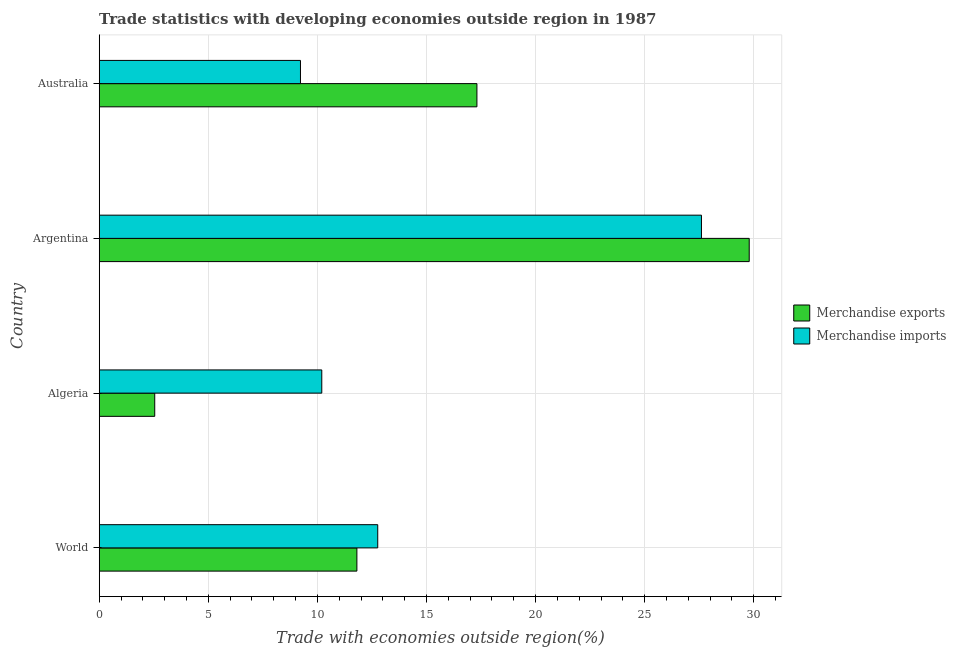Are the number of bars per tick equal to the number of legend labels?
Provide a succinct answer. Yes. How many bars are there on the 1st tick from the bottom?
Keep it short and to the point. 2. What is the label of the 2nd group of bars from the top?
Keep it short and to the point. Argentina. What is the merchandise exports in World?
Offer a very short reply. 11.81. Across all countries, what is the maximum merchandise imports?
Make the answer very short. 27.6. Across all countries, what is the minimum merchandise exports?
Offer a very short reply. 2.54. In which country was the merchandise imports minimum?
Keep it short and to the point. Australia. What is the total merchandise imports in the graph?
Offer a terse response. 59.79. What is the difference between the merchandise imports in World and the merchandise exports in Australia?
Your answer should be compact. -4.55. What is the average merchandise imports per country?
Your answer should be very brief. 14.95. What is the difference between the merchandise exports and merchandise imports in World?
Ensure brevity in your answer.  -0.95. What is the ratio of the merchandise exports in Argentina to that in World?
Provide a succinct answer. 2.52. Is the merchandise exports in Australia less than that in World?
Give a very brief answer. No. Is the difference between the merchandise imports in Algeria and Australia greater than the difference between the merchandise exports in Algeria and Australia?
Your answer should be very brief. Yes. What is the difference between the highest and the second highest merchandise exports?
Give a very brief answer. 12.48. What is the difference between the highest and the lowest merchandise imports?
Your response must be concise. 18.38. What does the 2nd bar from the top in World represents?
Your answer should be compact. Merchandise exports. What does the 1st bar from the bottom in World represents?
Offer a terse response. Merchandise exports. How many bars are there?
Offer a very short reply. 8. Are all the bars in the graph horizontal?
Give a very brief answer. Yes. How many countries are there in the graph?
Keep it short and to the point. 4. Are the values on the major ticks of X-axis written in scientific E-notation?
Offer a very short reply. No. Does the graph contain any zero values?
Keep it short and to the point. No. Does the graph contain grids?
Provide a succinct answer. Yes. Where does the legend appear in the graph?
Ensure brevity in your answer.  Center right. How are the legend labels stacked?
Your response must be concise. Vertical. What is the title of the graph?
Offer a terse response. Trade statistics with developing economies outside region in 1987. What is the label or title of the X-axis?
Your answer should be compact. Trade with economies outside region(%). What is the label or title of the Y-axis?
Provide a succinct answer. Country. What is the Trade with economies outside region(%) in Merchandise exports in World?
Ensure brevity in your answer.  11.81. What is the Trade with economies outside region(%) of Merchandise imports in World?
Ensure brevity in your answer.  12.76. What is the Trade with economies outside region(%) in Merchandise exports in Algeria?
Give a very brief answer. 2.54. What is the Trade with economies outside region(%) of Merchandise imports in Algeria?
Your answer should be very brief. 10.2. What is the Trade with economies outside region(%) in Merchandise exports in Argentina?
Make the answer very short. 29.79. What is the Trade with economies outside region(%) in Merchandise imports in Argentina?
Keep it short and to the point. 27.6. What is the Trade with economies outside region(%) in Merchandise exports in Australia?
Provide a short and direct response. 17.31. What is the Trade with economies outside region(%) of Merchandise imports in Australia?
Ensure brevity in your answer.  9.22. Across all countries, what is the maximum Trade with economies outside region(%) of Merchandise exports?
Your answer should be very brief. 29.79. Across all countries, what is the maximum Trade with economies outside region(%) of Merchandise imports?
Offer a terse response. 27.6. Across all countries, what is the minimum Trade with economies outside region(%) of Merchandise exports?
Your answer should be very brief. 2.54. Across all countries, what is the minimum Trade with economies outside region(%) in Merchandise imports?
Your answer should be very brief. 9.22. What is the total Trade with economies outside region(%) of Merchandise exports in the graph?
Give a very brief answer. 61.45. What is the total Trade with economies outside region(%) of Merchandise imports in the graph?
Your answer should be compact. 59.79. What is the difference between the Trade with economies outside region(%) in Merchandise exports in World and that in Algeria?
Give a very brief answer. 9.27. What is the difference between the Trade with economies outside region(%) of Merchandise imports in World and that in Algeria?
Offer a terse response. 2.56. What is the difference between the Trade with economies outside region(%) in Merchandise exports in World and that in Argentina?
Give a very brief answer. -17.98. What is the difference between the Trade with economies outside region(%) in Merchandise imports in World and that in Argentina?
Provide a succinct answer. -14.84. What is the difference between the Trade with economies outside region(%) of Merchandise exports in World and that in Australia?
Ensure brevity in your answer.  -5.5. What is the difference between the Trade with economies outside region(%) in Merchandise imports in World and that in Australia?
Make the answer very short. 3.54. What is the difference between the Trade with economies outside region(%) in Merchandise exports in Algeria and that in Argentina?
Give a very brief answer. -27.25. What is the difference between the Trade with economies outside region(%) in Merchandise imports in Algeria and that in Argentina?
Offer a terse response. -17.4. What is the difference between the Trade with economies outside region(%) in Merchandise exports in Algeria and that in Australia?
Make the answer very short. -14.77. What is the difference between the Trade with economies outside region(%) in Merchandise imports in Algeria and that in Australia?
Your answer should be very brief. 0.98. What is the difference between the Trade with economies outside region(%) of Merchandise exports in Argentina and that in Australia?
Ensure brevity in your answer.  12.48. What is the difference between the Trade with economies outside region(%) of Merchandise imports in Argentina and that in Australia?
Offer a very short reply. 18.38. What is the difference between the Trade with economies outside region(%) of Merchandise exports in World and the Trade with economies outside region(%) of Merchandise imports in Algeria?
Make the answer very short. 1.61. What is the difference between the Trade with economies outside region(%) of Merchandise exports in World and the Trade with economies outside region(%) of Merchandise imports in Argentina?
Make the answer very short. -15.79. What is the difference between the Trade with economies outside region(%) in Merchandise exports in World and the Trade with economies outside region(%) in Merchandise imports in Australia?
Ensure brevity in your answer.  2.59. What is the difference between the Trade with economies outside region(%) of Merchandise exports in Algeria and the Trade with economies outside region(%) of Merchandise imports in Argentina?
Keep it short and to the point. -25.06. What is the difference between the Trade with economies outside region(%) in Merchandise exports in Algeria and the Trade with economies outside region(%) in Merchandise imports in Australia?
Offer a terse response. -6.68. What is the difference between the Trade with economies outside region(%) of Merchandise exports in Argentina and the Trade with economies outside region(%) of Merchandise imports in Australia?
Ensure brevity in your answer.  20.57. What is the average Trade with economies outside region(%) in Merchandise exports per country?
Your response must be concise. 15.36. What is the average Trade with economies outside region(%) of Merchandise imports per country?
Provide a succinct answer. 14.95. What is the difference between the Trade with economies outside region(%) in Merchandise exports and Trade with economies outside region(%) in Merchandise imports in World?
Your response must be concise. -0.95. What is the difference between the Trade with economies outside region(%) in Merchandise exports and Trade with economies outside region(%) in Merchandise imports in Algeria?
Ensure brevity in your answer.  -7.66. What is the difference between the Trade with economies outside region(%) in Merchandise exports and Trade with economies outside region(%) in Merchandise imports in Argentina?
Provide a succinct answer. 2.19. What is the difference between the Trade with economies outside region(%) of Merchandise exports and Trade with economies outside region(%) of Merchandise imports in Australia?
Make the answer very short. 8.09. What is the ratio of the Trade with economies outside region(%) in Merchandise exports in World to that in Algeria?
Give a very brief answer. 4.64. What is the ratio of the Trade with economies outside region(%) in Merchandise imports in World to that in Algeria?
Offer a terse response. 1.25. What is the ratio of the Trade with economies outside region(%) of Merchandise exports in World to that in Argentina?
Offer a terse response. 0.4. What is the ratio of the Trade with economies outside region(%) in Merchandise imports in World to that in Argentina?
Your answer should be compact. 0.46. What is the ratio of the Trade with economies outside region(%) of Merchandise exports in World to that in Australia?
Provide a succinct answer. 0.68. What is the ratio of the Trade with economies outside region(%) in Merchandise imports in World to that in Australia?
Offer a terse response. 1.38. What is the ratio of the Trade with economies outside region(%) in Merchandise exports in Algeria to that in Argentina?
Your response must be concise. 0.09. What is the ratio of the Trade with economies outside region(%) of Merchandise imports in Algeria to that in Argentina?
Offer a very short reply. 0.37. What is the ratio of the Trade with economies outside region(%) in Merchandise exports in Algeria to that in Australia?
Your answer should be very brief. 0.15. What is the ratio of the Trade with economies outside region(%) in Merchandise imports in Algeria to that in Australia?
Give a very brief answer. 1.11. What is the ratio of the Trade with economies outside region(%) in Merchandise exports in Argentina to that in Australia?
Provide a short and direct response. 1.72. What is the ratio of the Trade with economies outside region(%) in Merchandise imports in Argentina to that in Australia?
Make the answer very short. 2.99. What is the difference between the highest and the second highest Trade with economies outside region(%) of Merchandise exports?
Make the answer very short. 12.48. What is the difference between the highest and the second highest Trade with economies outside region(%) of Merchandise imports?
Provide a short and direct response. 14.84. What is the difference between the highest and the lowest Trade with economies outside region(%) of Merchandise exports?
Give a very brief answer. 27.25. What is the difference between the highest and the lowest Trade with economies outside region(%) of Merchandise imports?
Your response must be concise. 18.38. 